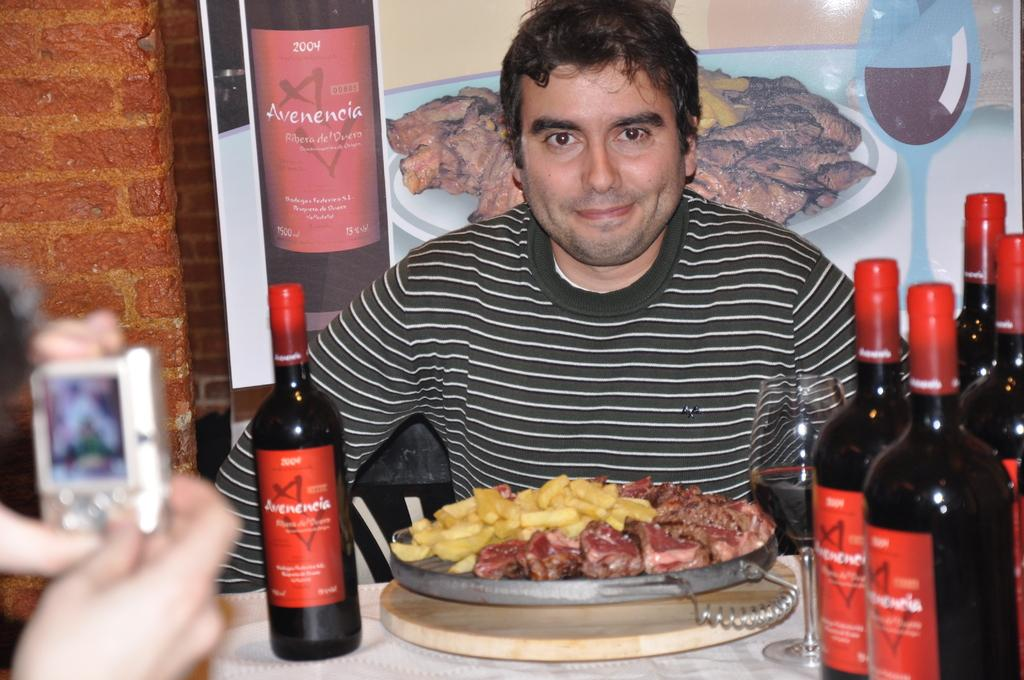<image>
Relay a brief, clear account of the picture shown. Avenencia wine bottles with a man that is eating a meal. 